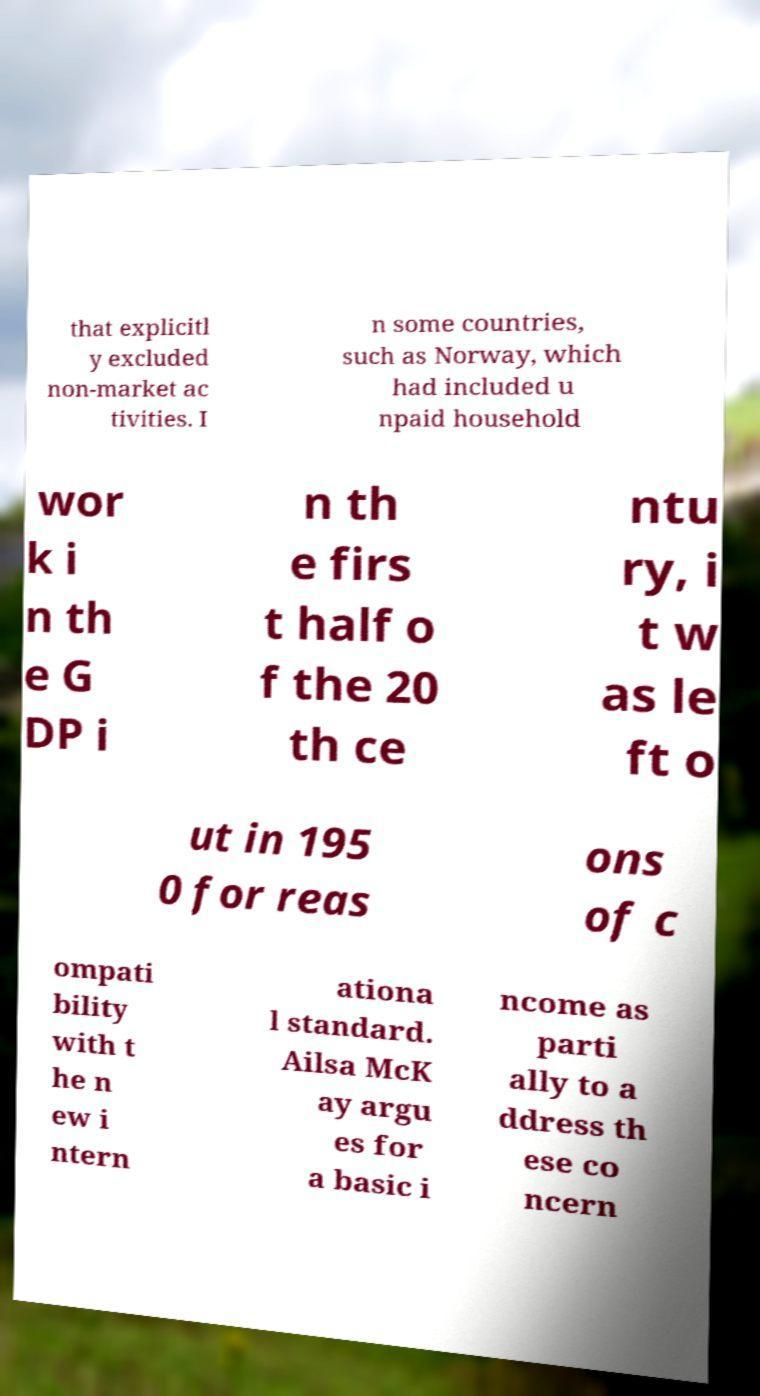Please read and relay the text visible in this image. What does it say? that explicitl y excluded non-market ac tivities. I n some countries, such as Norway, which had included u npaid household wor k i n th e G DP i n th e firs t half o f the 20 th ce ntu ry, i t w as le ft o ut in 195 0 for reas ons of c ompati bility with t he n ew i ntern ationa l standard. Ailsa McK ay argu es for a basic i ncome as parti ally to a ddress th ese co ncern 